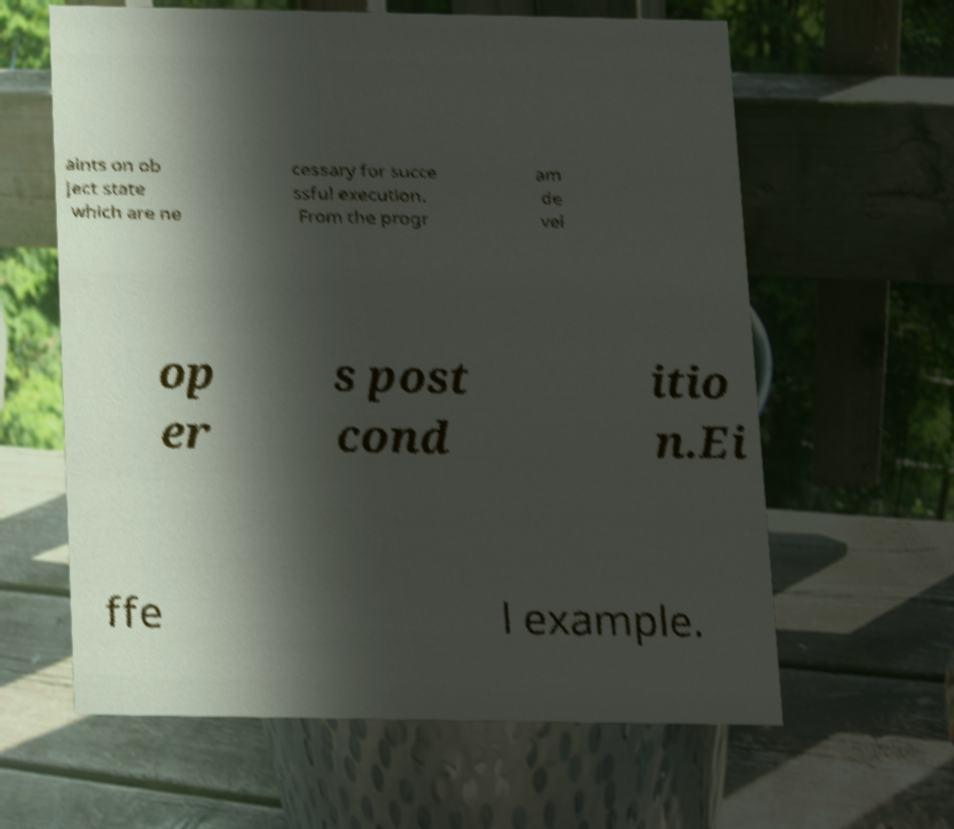For documentation purposes, I need the text within this image transcribed. Could you provide that? aints on ob ject state which are ne cessary for succe ssful execution. From the progr am de vel op er s post cond itio n.Ei ffe l example. 